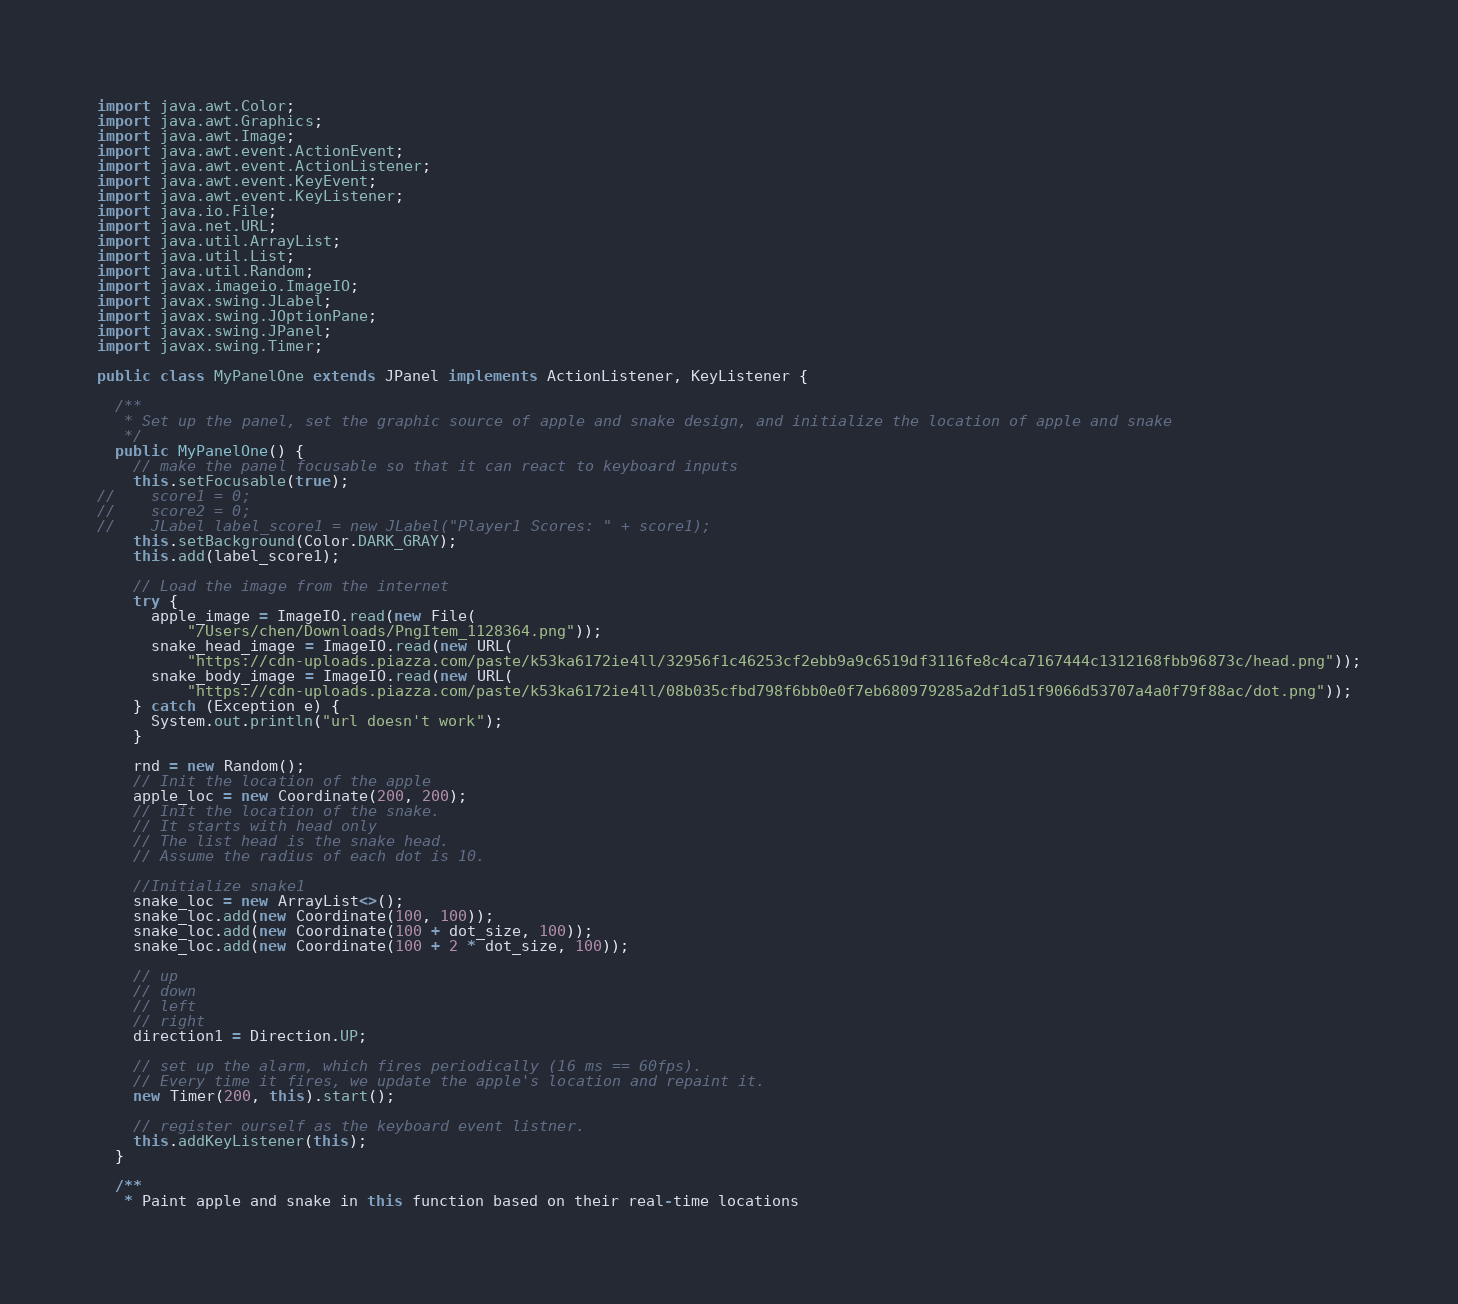<code> <loc_0><loc_0><loc_500><loc_500><_Java_>import java.awt.Color;
import java.awt.Graphics;
import java.awt.Image;
import java.awt.event.ActionEvent;
import java.awt.event.ActionListener;
import java.awt.event.KeyEvent;
import java.awt.event.KeyListener;
import java.io.File;
import java.net.URL;
import java.util.ArrayList;
import java.util.List;
import java.util.Random;
import javax.imageio.ImageIO;
import javax.swing.JLabel;
import javax.swing.JOptionPane;
import javax.swing.JPanel;
import javax.swing.Timer;

public class MyPanelOne extends JPanel implements ActionListener, KeyListener {

  /**
   * Set up the panel, set the graphic source of apple and snake design, and initialize the location of apple and snake
   */
  public MyPanelOne() {
    // make the panel focusable so that it can react to keyboard inputs
    this.setFocusable(true);
//    score1 = 0;
//    score2 = 0;
//    JLabel label_score1 = new JLabel("Player1 Scores: " + score1);
    this.setBackground(Color.DARK_GRAY);
    this.add(label_score1);

    // Load the image from the internet
    try {
      apple_image = ImageIO.read(new File(
          "/Users/chen/Downloads/PngItem_1128364.png"));
      snake_head_image = ImageIO.read(new URL(
          "https://cdn-uploads.piazza.com/paste/k53ka6172ie4ll/32956f1c46253cf2ebb9a9c6519df3116fe8c4ca7167444c1312168fbb96873c/head.png"));
      snake_body_image = ImageIO.read(new URL(
          "https://cdn-uploads.piazza.com/paste/k53ka6172ie4ll/08b035cfbd798f6bb0e0f7eb680979285a2df1d51f9066d53707a4a0f79f88ac/dot.png"));
    } catch (Exception e) {
      System.out.println("url doesn't work");
    }

    rnd = new Random();
    // Init the location of the apple
    apple_loc = new Coordinate(200, 200);
    // Init the location of the snake.
    // It starts with head only
    // The list head is the snake head.
    // Assume the radius of each dot is 10.

    //Initialize snake1
    snake_loc = new ArrayList<>();
    snake_loc.add(new Coordinate(100, 100));
    snake_loc.add(new Coordinate(100 + dot_size, 100));
    snake_loc.add(new Coordinate(100 + 2 * dot_size, 100));

    // up
    // down
    // left
    // right
    direction1 = Direction.UP;

    // set up the alarm, which fires periodically (16 ms == 60fps).
    // Every time it fires, we update the apple's location and repaint it.
    new Timer(200, this).start();

    // register ourself as the keyboard event listner.
    this.addKeyListener(this);
  }

  /**
   * Paint apple and snake in this function based on their real-time locations</code> 